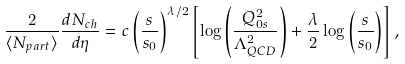Convert formula to latex. <formula><loc_0><loc_0><loc_500><loc_500>\frac { 2 } { \langle N _ { p a r t } \rangle } \frac { d N _ { c h } } { d \eta } = c \left ( \frac { s } { s _ { 0 } } \right ) ^ { \lambda / 2 } \left [ \log \left ( \frac { Q _ { 0 s } ^ { 2 } } { \Lambda _ { Q C D } ^ { 2 } } \right ) + \frac { \lambda } { 2 } \log \left ( \frac { s } { s _ { 0 } } \right ) \right ] ,</formula> 